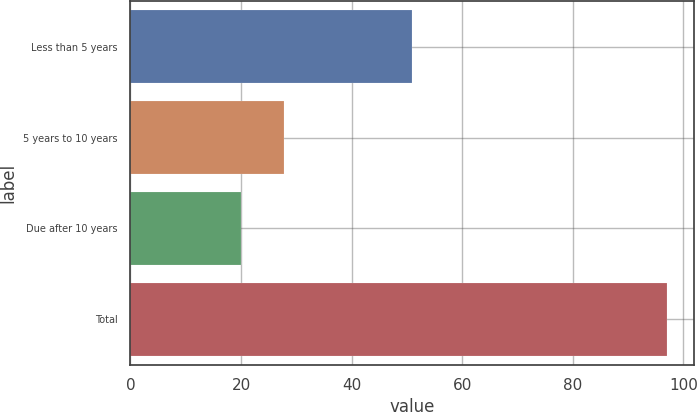Convert chart. <chart><loc_0><loc_0><loc_500><loc_500><bar_chart><fcel>Less than 5 years<fcel>5 years to 10 years<fcel>Due after 10 years<fcel>Total<nl><fcel>51<fcel>27.7<fcel>20<fcel>97<nl></chart> 